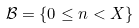<formula> <loc_0><loc_0><loc_500><loc_500>\mathcal { B } = \{ 0 \leq n < X \}</formula> 